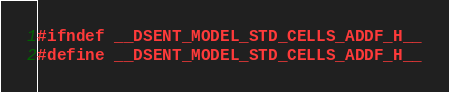<code> <loc_0><loc_0><loc_500><loc_500><_C_>#ifndef __DSENT_MODEL_STD_CELLS_ADDF_H__
#define __DSENT_MODEL_STD_CELLS_ADDF_H__
</code> 